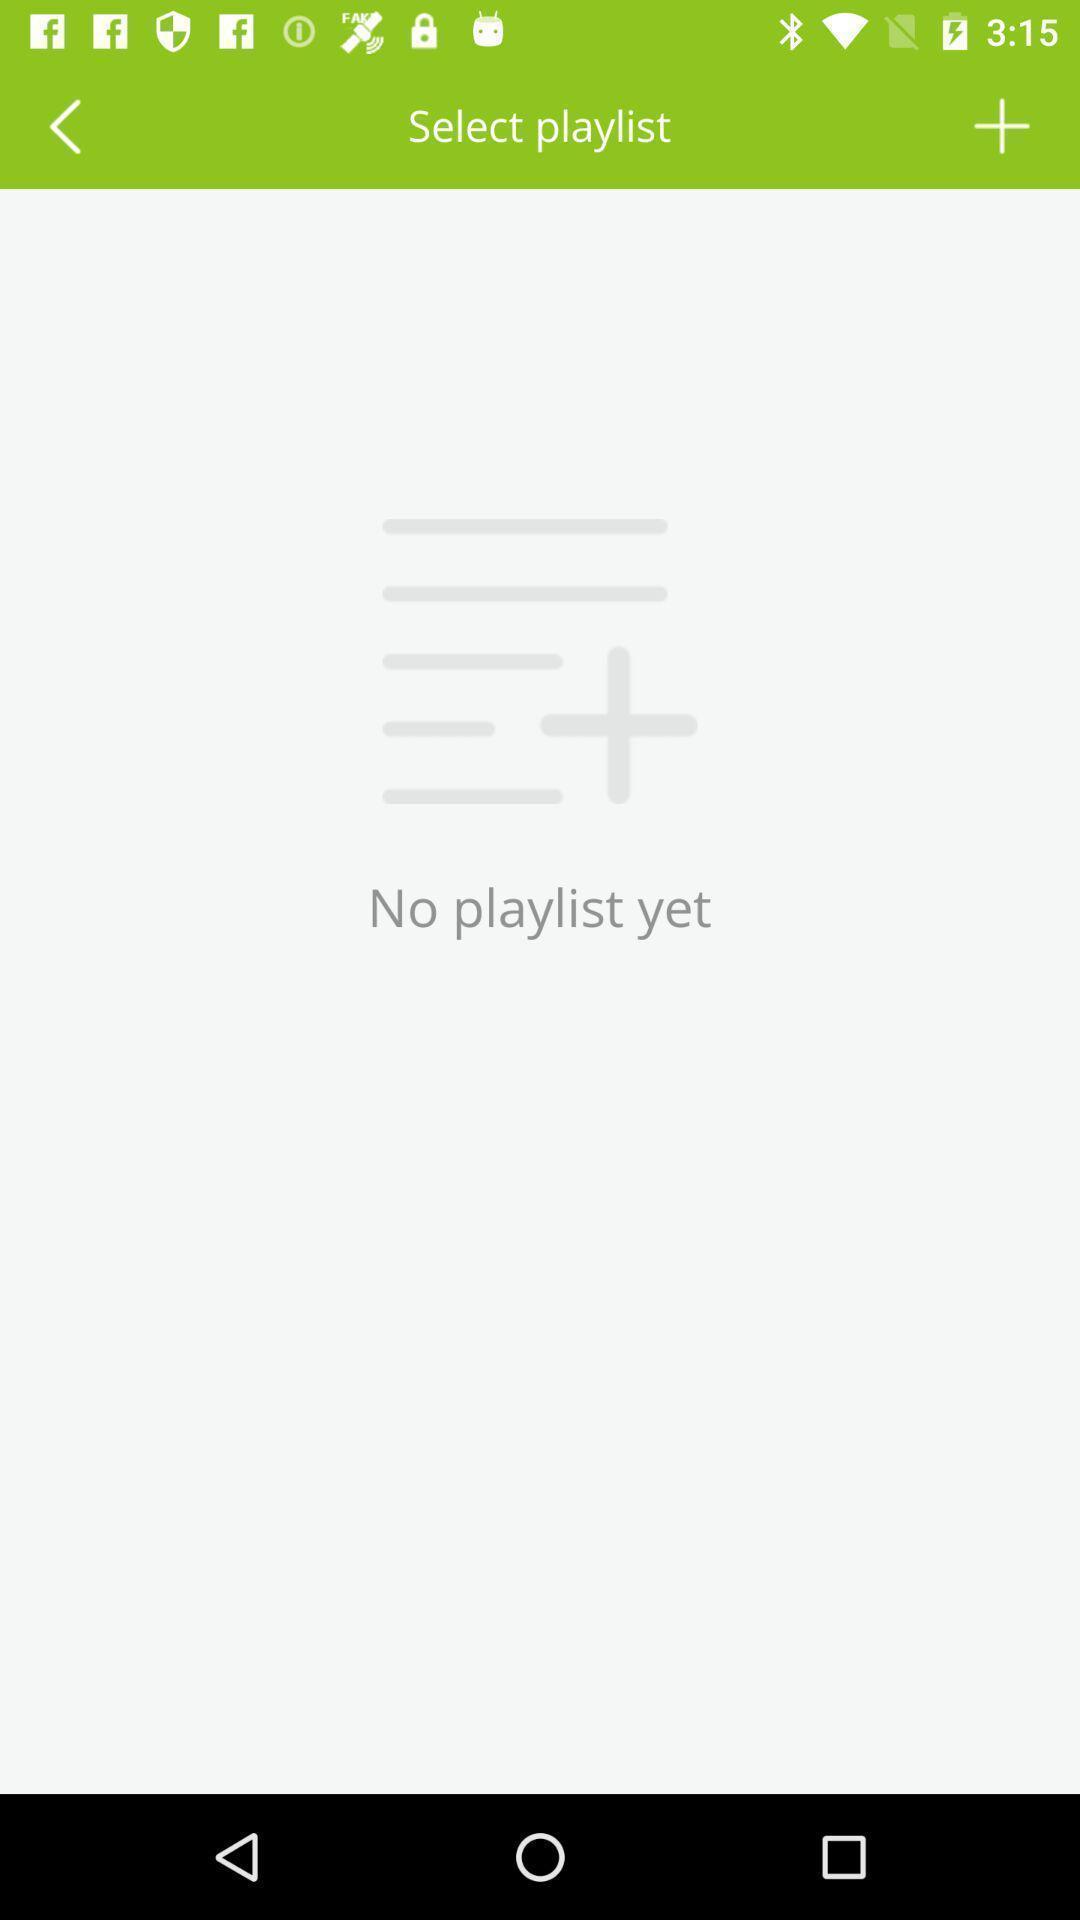Please provide a description for this image. Page that displaying results of a playlist. 